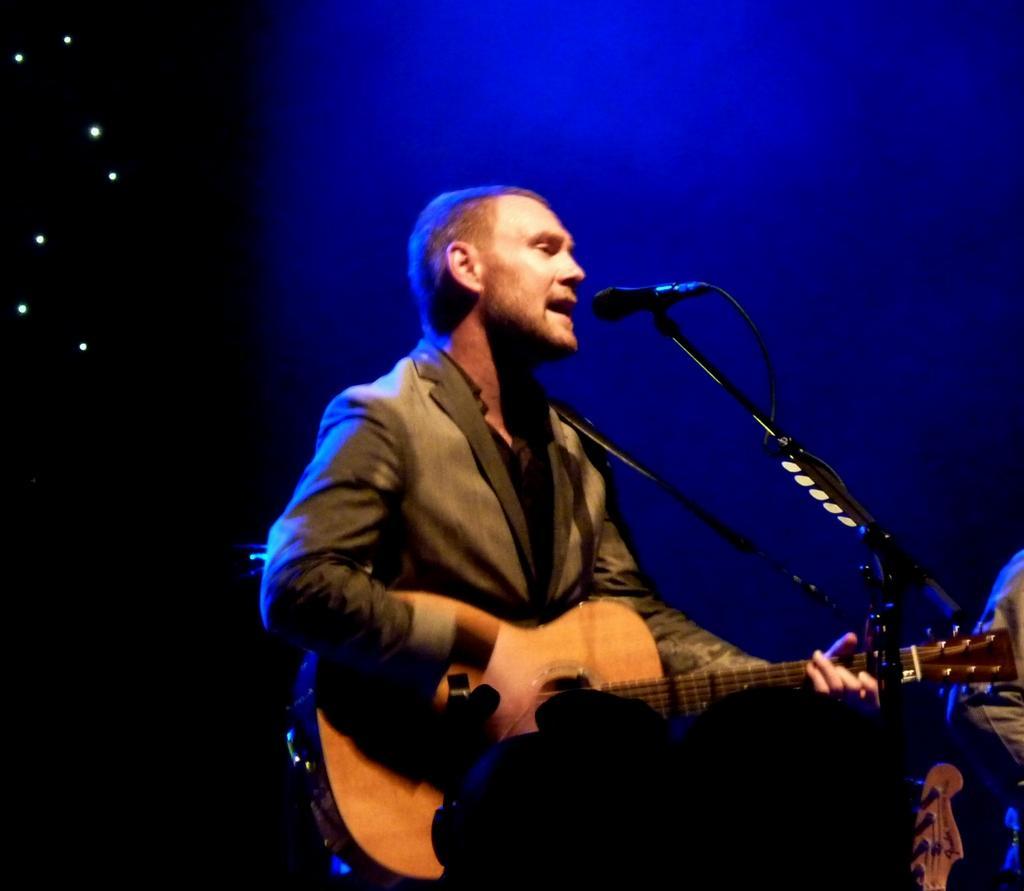Please provide a concise description of this image. In this picture we can see a man who is standing in front of mike. And he is playing guitar. On the background we can see some lights. 